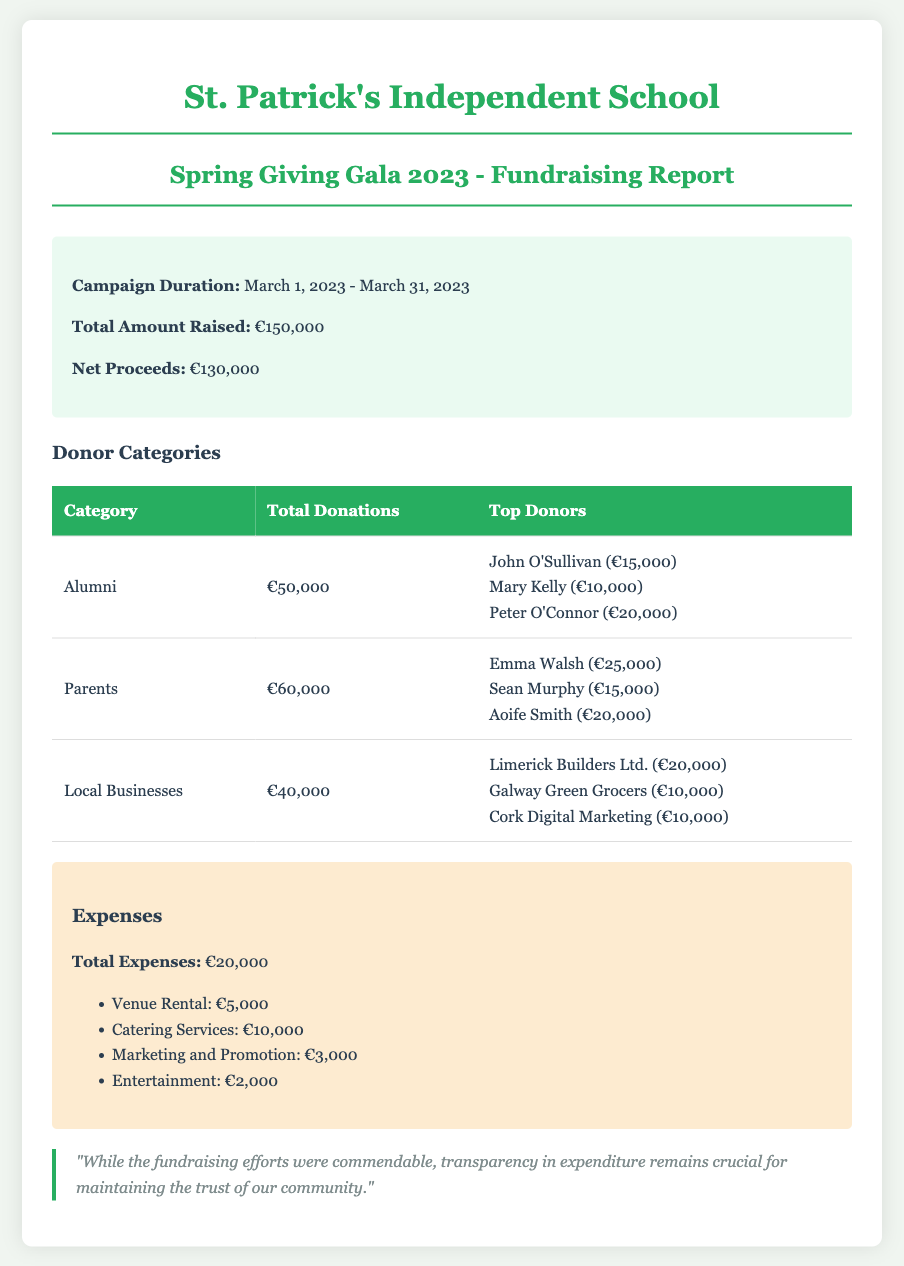What is the total amount raised? The total amount raised is stated in the summary section of the document.
Answer: €150,000 What were the campaign dates? The campaign duration is provided in the summary section.
Answer: March 1, 2023 - March 31, 2023 How much did parents contribute? The total donations from parents are listed under the Donor Categories table.
Answer: €60,000 Who is the top donor from the alumni category? The top donors from the alumni category are detailed in the Donor Categories table.
Answer: Peter O'Connor (€20,000) What was the total expenses amount? The total expenses are noted in the expenses section of the document.
Answer: €20,000 What is a key concern mentioned in the comment? The comment section highlights a concern regarding transparency in expenditure.
Answer: Transparency How much did local businesses donate in total? The total donations from local businesses can be found in the Donor Categories table.
Answer: €40,000 What was the highest single donation from alumni? The highest single donation from alumni is mentioned in the Donor Categories table.
Answer: €20,000 How much was spent on catering services? The specific expense for catering services is provided in the expenses section.
Answer: €10,000 